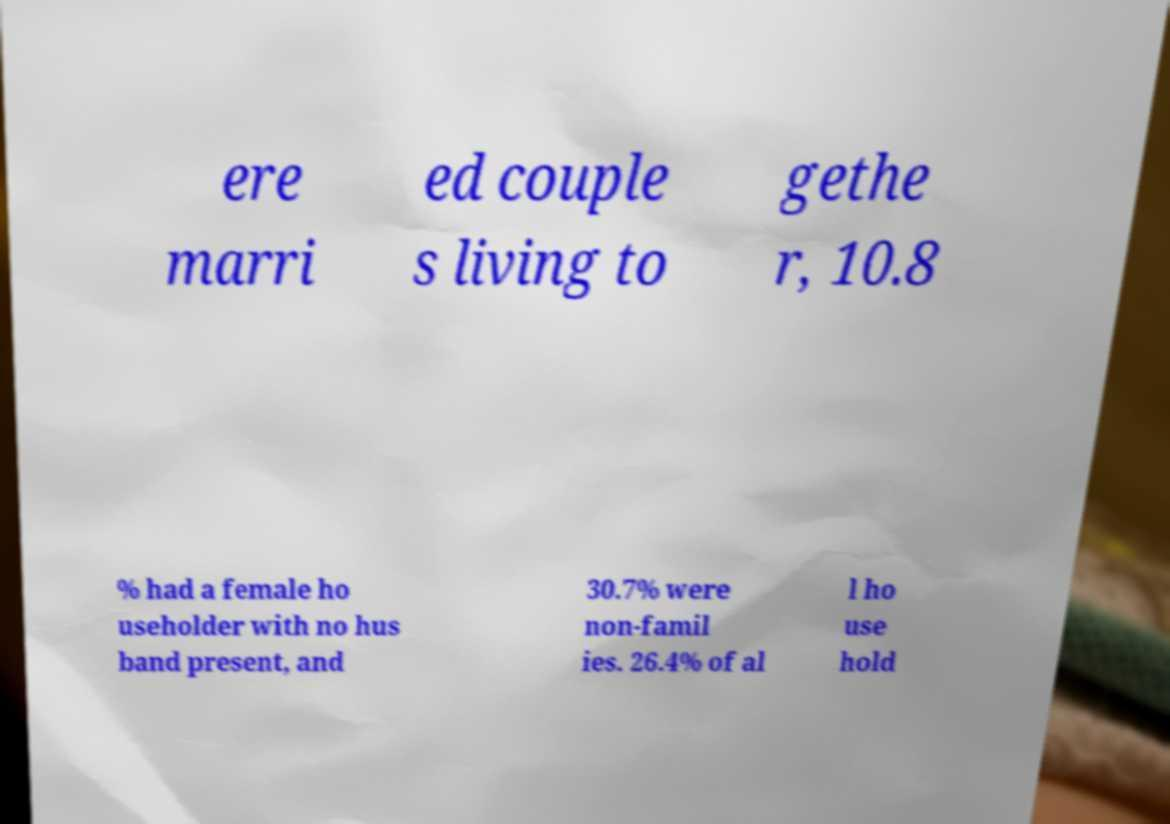Could you assist in decoding the text presented in this image and type it out clearly? ere marri ed couple s living to gethe r, 10.8 % had a female ho useholder with no hus band present, and 30.7% were non-famil ies. 26.4% of al l ho use hold 